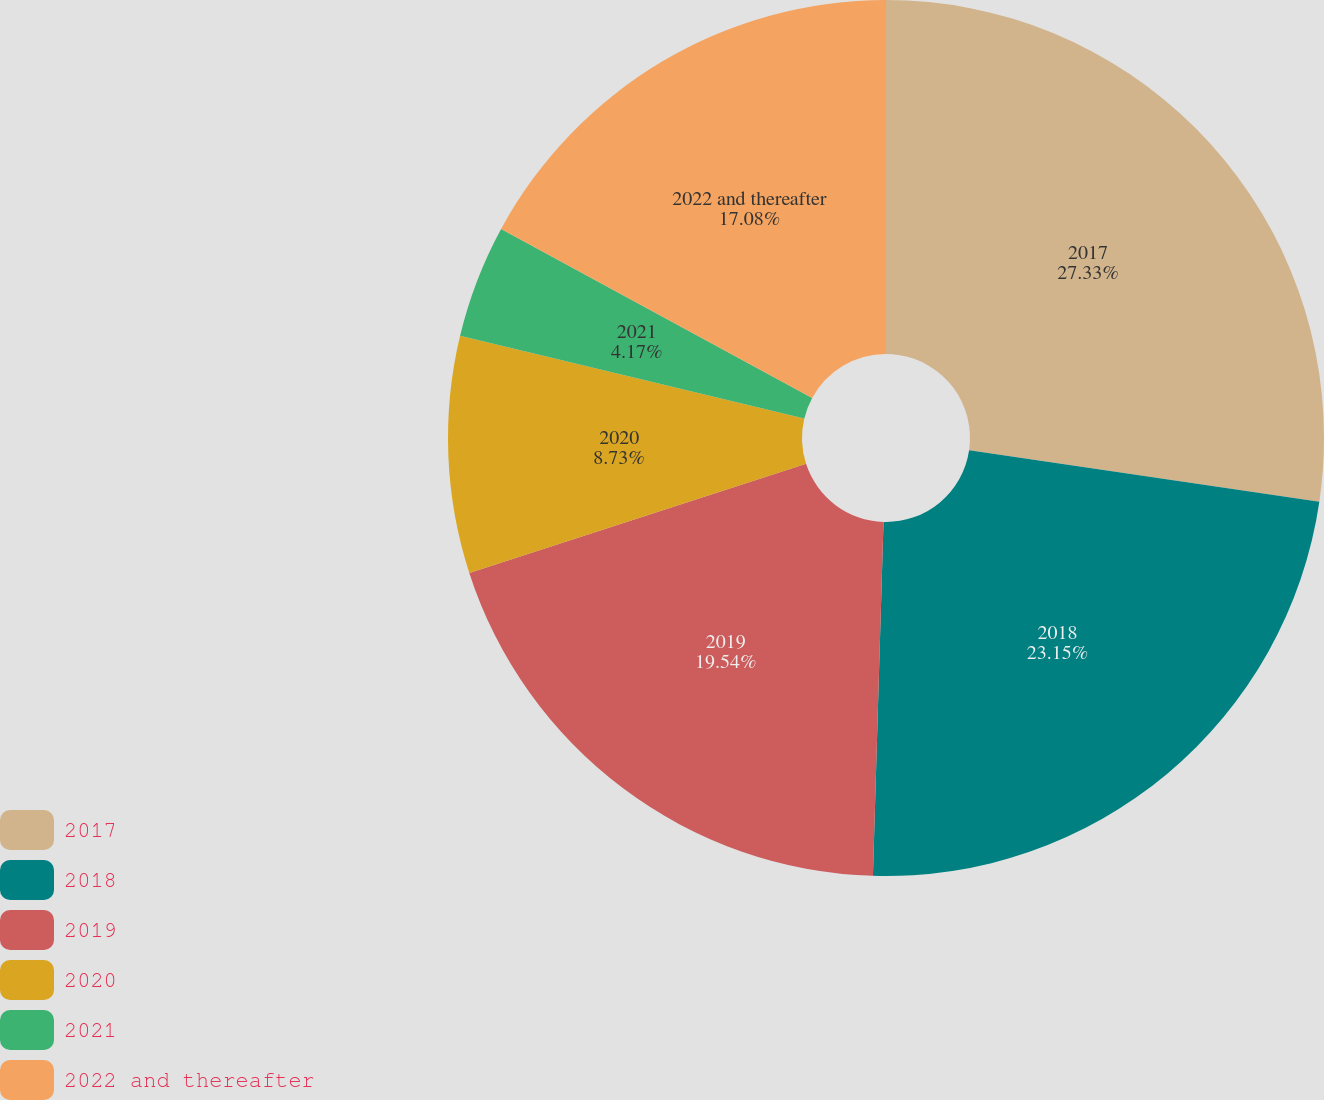Convert chart to OTSL. <chart><loc_0><loc_0><loc_500><loc_500><pie_chart><fcel>2017<fcel>2018<fcel>2019<fcel>2020<fcel>2021<fcel>2022 and thereafter<nl><fcel>27.32%<fcel>23.15%<fcel>19.54%<fcel>8.73%<fcel>4.17%<fcel>17.08%<nl></chart> 